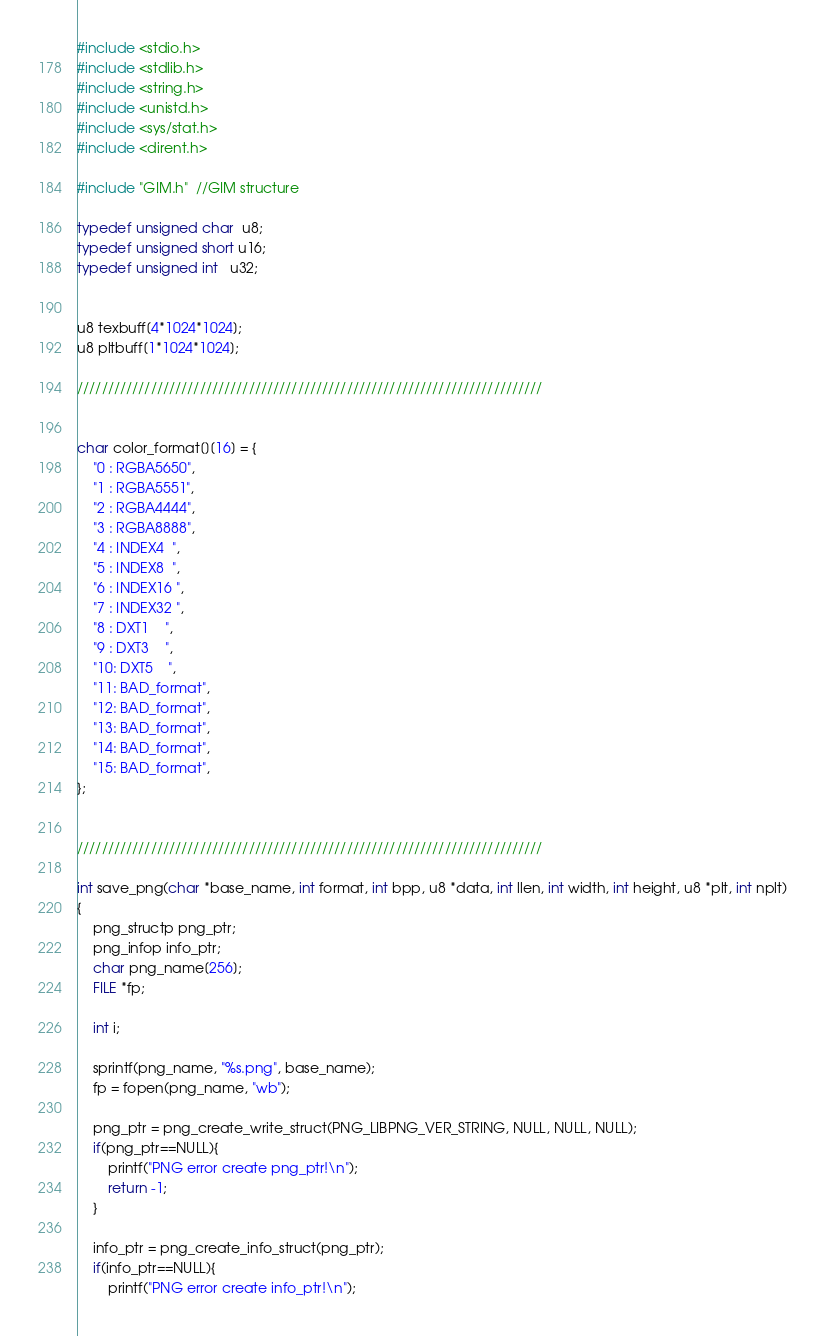<code> <loc_0><loc_0><loc_500><loc_500><_C++_>#include <stdio.h>
#include <stdlib.h>
#include <string.h>
#include <unistd.h>
#include <sys/stat.h>
#include <dirent.h>

#include "GIM.h"  //GIM structure

typedef unsigned char  u8;
typedef unsigned short u16;
typedef unsigned int   u32;


u8 texbuff[4*1024*1024];
u8 pltbuff[1*1024*1024];

////////////////////////////////////////////////////////////////////////////


char color_format[][16] = {
	"0 : RGBA5650",
	"1 : RGBA5551",
	"2 : RGBA4444",
	"3 : RGBA8888",
	"4 : INDEX4  ",
	"5 : INDEX8  ",
	"6 : INDEX16 ",
	"7 : INDEX32 ",
	"8 : DXT1    ",
	"9 : DXT3    ",
	"10: DXT5    ",
	"11: BAD_format",
	"12: BAD_format",
	"13: BAD_format",
	"14: BAD_format",
	"15: BAD_format",
};


////////////////////////////////////////////////////////////////////////////

int save_png(char *base_name, int format, int bpp, u8 *data, int llen, int width, int height, u8 *plt, int nplt)
{
	png_structp png_ptr;
	png_infop info_ptr;
	char png_name[256];
	FILE *fp;

	int i;

	sprintf(png_name, "%s.png", base_name);
	fp = fopen(png_name, "wb");

	png_ptr = png_create_write_struct(PNG_LIBPNG_VER_STRING, NULL, NULL, NULL);
	if(png_ptr==NULL){
		printf("PNG error create png_ptr!\n");
		return -1;
	}

	info_ptr = png_create_info_struct(png_ptr);
	if(info_ptr==NULL){
		printf("PNG error create info_ptr!\n");</code> 